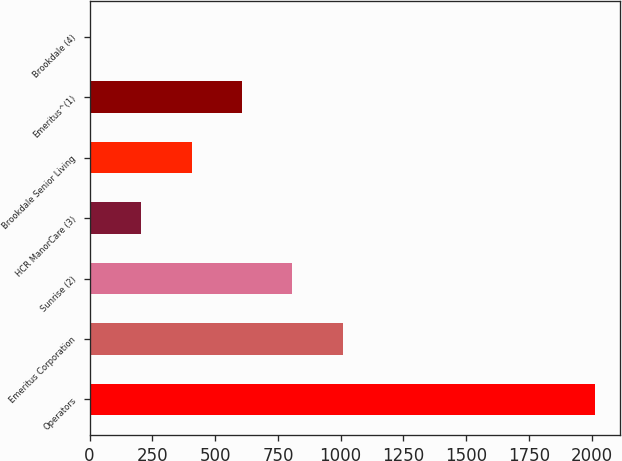Convert chart. <chart><loc_0><loc_0><loc_500><loc_500><bar_chart><fcel>Operators<fcel>Emeritus Corporation<fcel>Sunrise (2)<fcel>HCR ManorCare (3)<fcel>Brookdale Senior Living<fcel>Emeritus^(1)<fcel>Brookdale (4)<nl><fcel>2013<fcel>1008.5<fcel>807.6<fcel>204.9<fcel>405.8<fcel>606.7<fcel>4<nl></chart> 